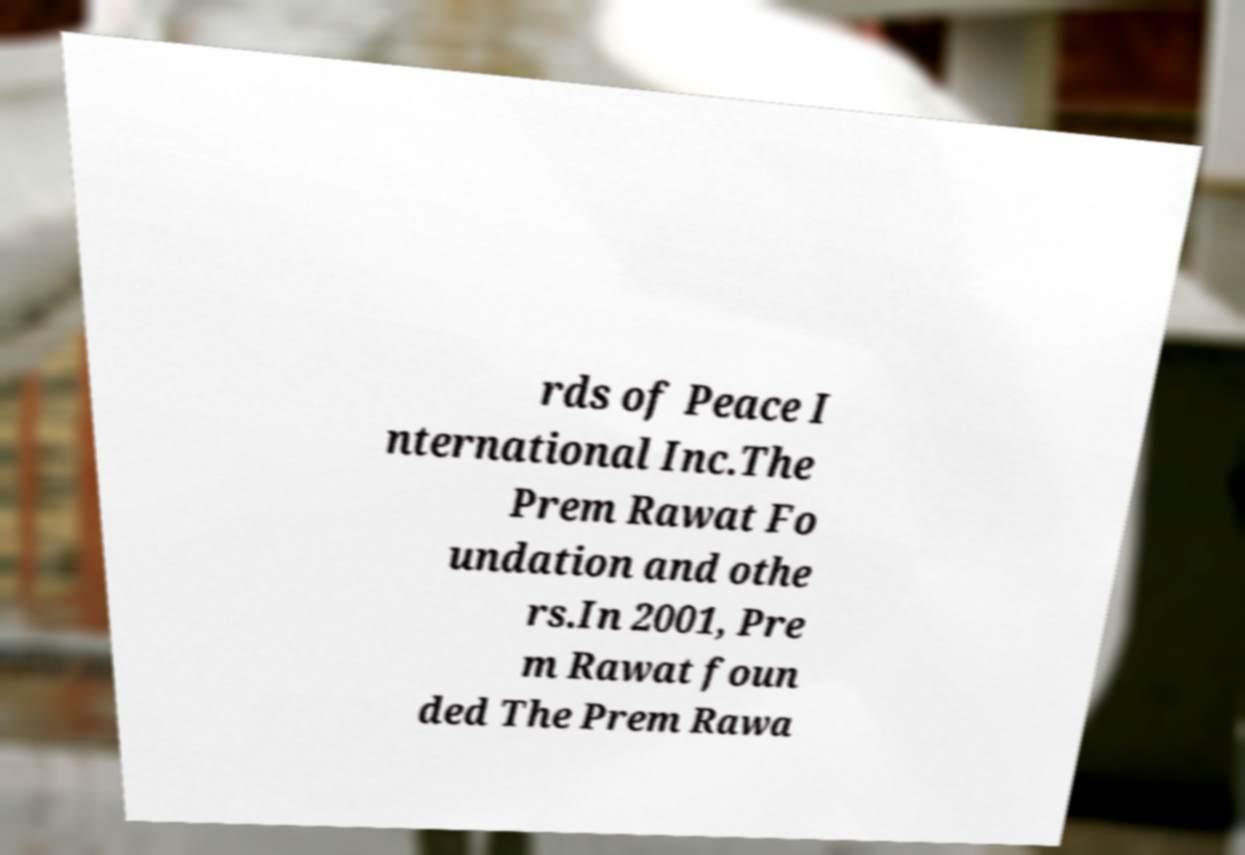Please read and relay the text visible in this image. What does it say? rds of Peace I nternational Inc.The Prem Rawat Fo undation and othe rs.In 2001, Pre m Rawat foun ded The Prem Rawa 